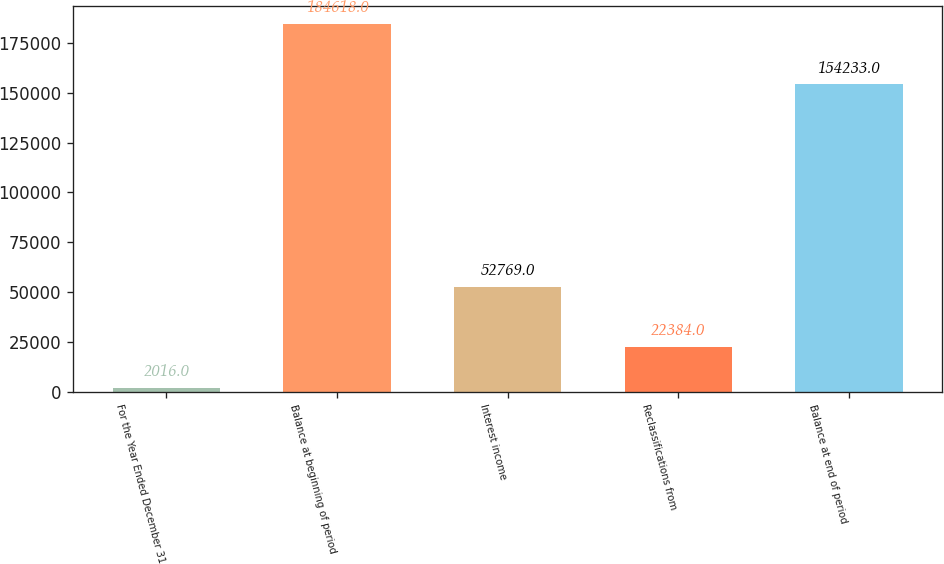Convert chart to OTSL. <chart><loc_0><loc_0><loc_500><loc_500><bar_chart><fcel>For the Year Ended December 31<fcel>Balance at beginning of period<fcel>Interest income<fcel>Reclassifications from<fcel>Balance at end of period<nl><fcel>2016<fcel>184618<fcel>52769<fcel>22384<fcel>154233<nl></chart> 